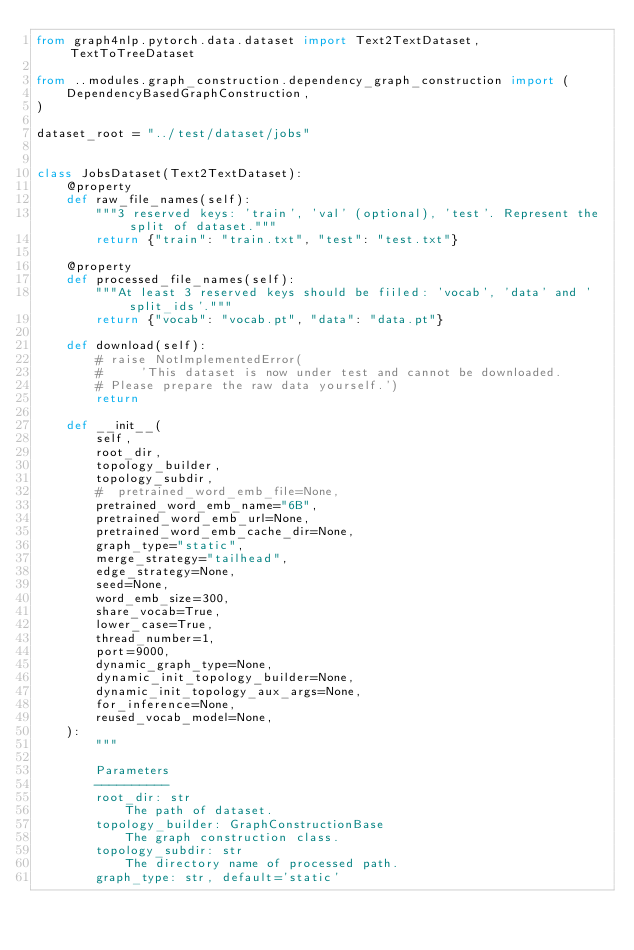<code> <loc_0><loc_0><loc_500><loc_500><_Python_>from graph4nlp.pytorch.data.dataset import Text2TextDataset, TextToTreeDataset

from ..modules.graph_construction.dependency_graph_construction import (
    DependencyBasedGraphConstruction,
)

dataset_root = "../test/dataset/jobs"


class JobsDataset(Text2TextDataset):
    @property
    def raw_file_names(self):
        """3 reserved keys: 'train', 'val' (optional), 'test'. Represent the split of dataset."""
        return {"train": "train.txt", "test": "test.txt"}

    @property
    def processed_file_names(self):
        """At least 3 reserved keys should be fiiled: 'vocab', 'data' and 'split_ids'."""
        return {"vocab": "vocab.pt", "data": "data.pt"}

    def download(self):
        # raise NotImplementedError(
        #     'This dataset is now under test and cannot be downloaded.
        # Please prepare the raw data yourself.')
        return

    def __init__(
        self,
        root_dir,
        topology_builder,
        topology_subdir,
        #  pretrained_word_emb_file=None,
        pretrained_word_emb_name="6B",
        pretrained_word_emb_url=None,
        pretrained_word_emb_cache_dir=None,
        graph_type="static",
        merge_strategy="tailhead",
        edge_strategy=None,
        seed=None,
        word_emb_size=300,
        share_vocab=True,
        lower_case=True,
        thread_number=1,
        port=9000,
        dynamic_graph_type=None,
        dynamic_init_topology_builder=None,
        dynamic_init_topology_aux_args=None,
        for_inference=None,
        reused_vocab_model=None,
    ):
        """

        Parameters
        ----------
        root_dir: str
            The path of dataset.
        topology_builder: GraphConstructionBase
            The graph construction class.
        topology_subdir: str
            The directory name of processed path.
        graph_type: str, default='static'</code> 